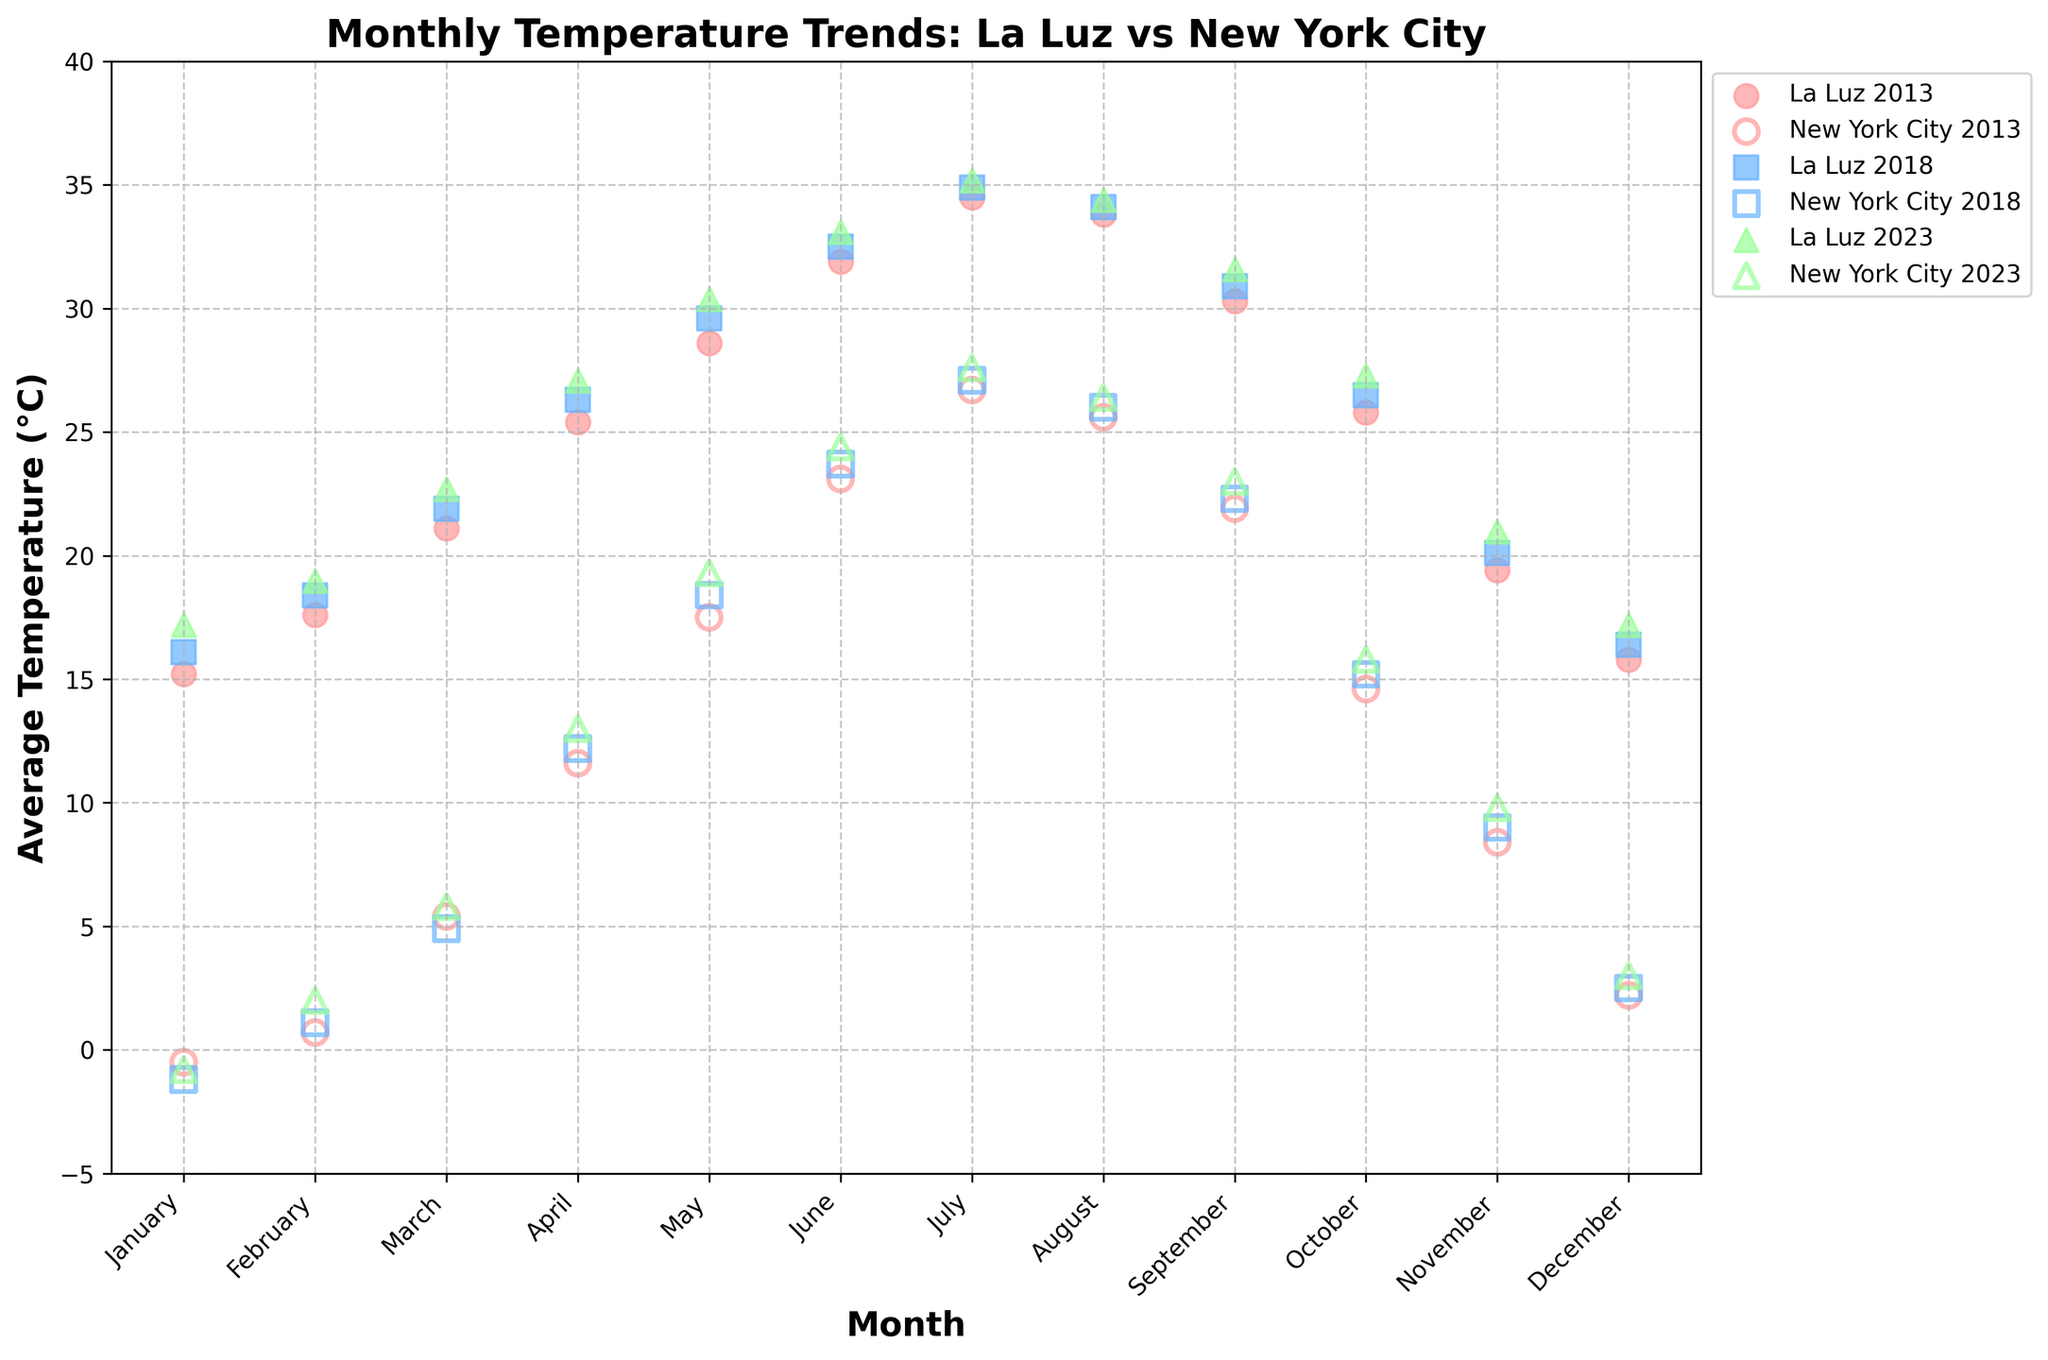What are the average temperatures for La Luz and New York City in July 2023? Locate the July 2023 markers for both La Luz and New York City. For July 2023, La Luz has an average temperature of 35.2°C, and New York City has an average temperature of 27.6°C
Answer: La Luz: 35.2°C, New York City: 27.6°C What is the overall trend in average temperatures in La Luz from January to December in 2023? Identify the trend by looking at the positions of the markers for each month in 2023. In general, the temperature increases from January (17.2°C), peaks in July (35.2°C), and then decreases through December (17.2°C)
Answer: Increases from January to July, decreases through December How do the January temperatures compare between La Luz and New York City across the three years? Check the January markers for the years 2013, 2018, and 2023 for both locations. La Luz temperatures: 15.2°C (2013), 16.1°C (2018), 17.2°C (2023). New York City temperatures: -0.5°C (2013), -1.2°C (2018), -0.8°C (2023)
Answer: La Luz January temperatures have increased, NY January temperatures have slightly decreased Which month shows the greatest difference in average temperature between La Luz and New York City in 2013? For each month in 2013, calculate the absolute difference between the temperatures of both locations. The largest difference is in July with La Luz at 34.5°C and New York City at 26.7°C, difference = 34.5 - 26.7 = 7.8
Answer: July What is the average temperature difference between La Luz and New York City across all months in 2018? For each month in 2018, calculate the temperature differences and find their average: (16.1 - (-1.2) + 18.4 - 1.1 + 21.9 - 4.9 + 26.3 - 12.2 + 29.6 - 18.4 + 32.5 - 23.7 + 34.9 - 27.1 + 34.1 - 26.0 + 30.9 - 22.3 + 26.5 - 15.2 + 20.1 - 9.0 + 16.4 - 2.5) / 12 = 10.99
Answer: 11.0°C Which location experiences a higher average temperature in October 2023, and what is the value? Check the October 2023 markers: La Luz's temperature is 27.3°C and New York City's temperature is 15.8°C
Answer: La Luz, 27.3°C How does the average temperature in La Luz in June (2013, 2018, 2023) compare to the average temperature in June for New York City in the same years? Calculate the average temperatures for June in each location across the three years. La Luz: (31.9 + 32.5 + 33.1) / 3 = 32.5°C, NYC: (23.1 + 23.7 + 24.4) / 3 = 23.73°C
Answer: La Luz experiences higher temperatures in June How has the temperature trend changed in New York City from January to December in 2023 compared to 2013? Compare the markers from January to December for 2023 and 2013. In 2023, the temperature starts at -0.8°C in January, peaks in July at 27.6°C, and ends at 3.0°C in December. In 2013, it starts at -0.5°C in January, peaks at 26.7°C in July, and ends at 2.2°C in December. The overall trend pattern is similar with a slight increase in peak temperatures in 2023
Answer: Similar trend with a slight increase in peak temperatures in 2023 